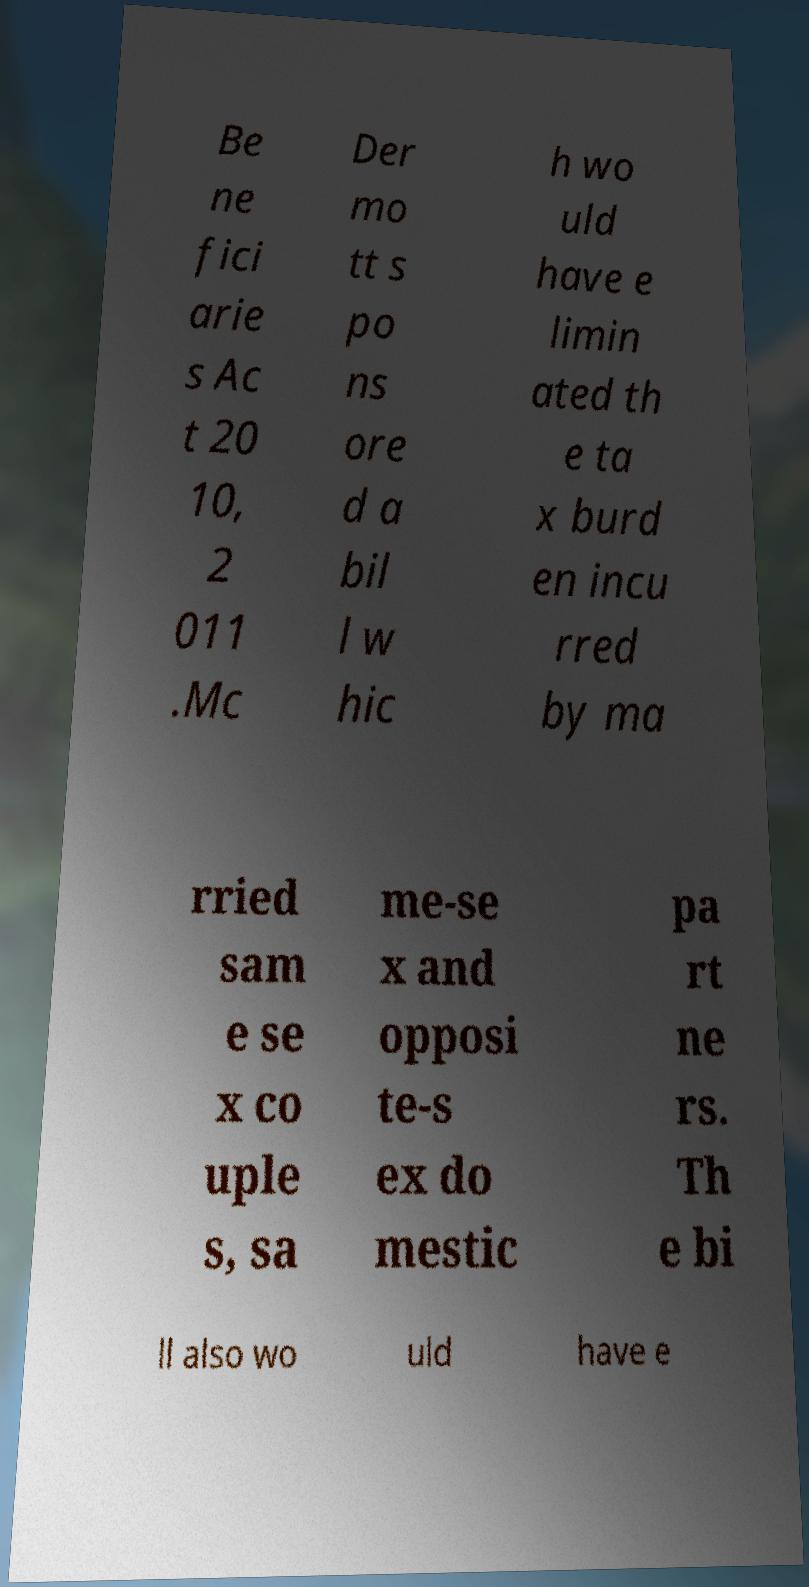There's text embedded in this image that I need extracted. Can you transcribe it verbatim? Be ne fici arie s Ac t 20 10, 2 011 .Mc Der mo tt s po ns ore d a bil l w hic h wo uld have e limin ated th e ta x burd en incu rred by ma rried sam e se x co uple s, sa me-se x and opposi te-s ex do mestic pa rt ne rs. Th e bi ll also wo uld have e 